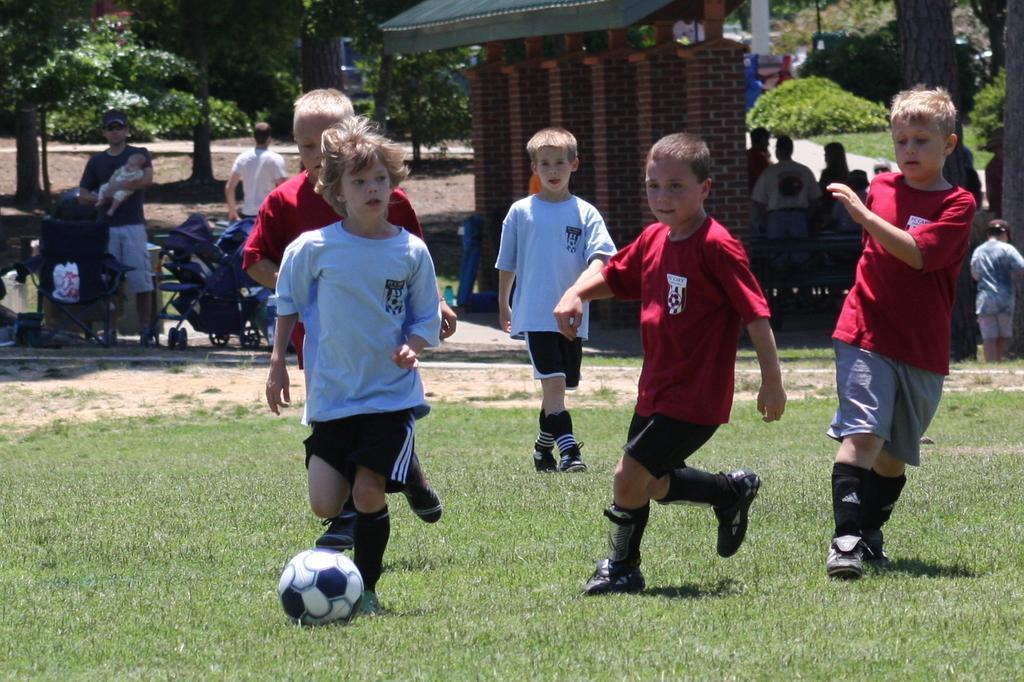In one or two sentences, can you explain what this image depicts? In this picture we can see children's playing football on ground and in background person holding baby in his hand and some more persons standing, trees, sun shade, grass, path. 